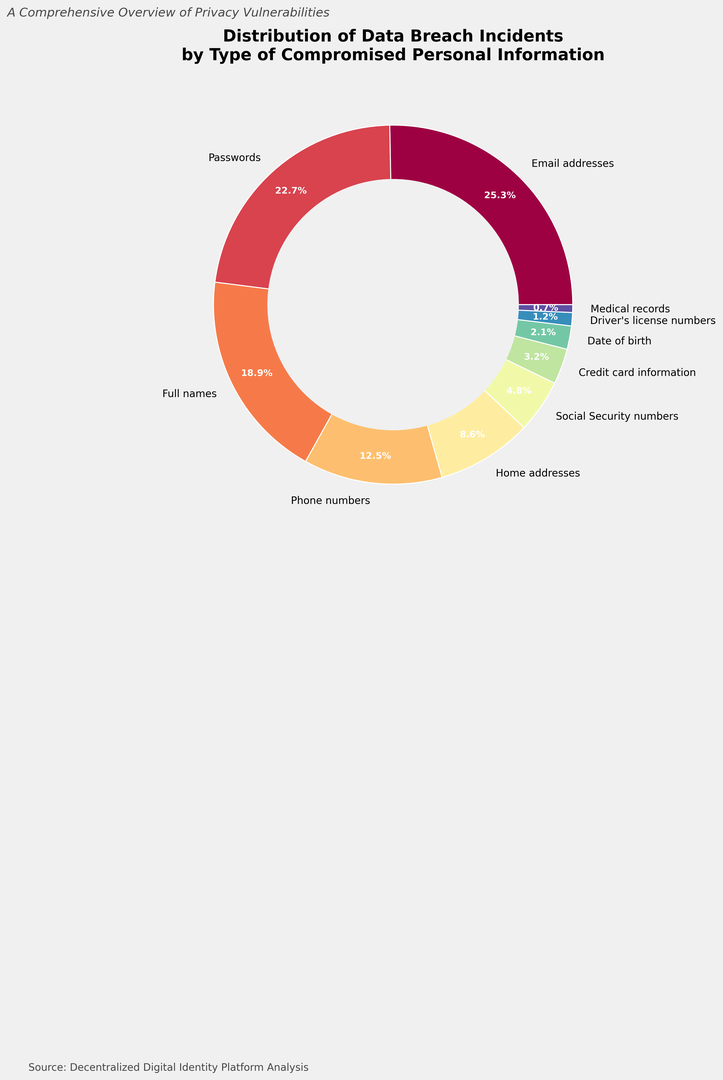Which type of compromised information is the most common? The figure shows that the percentage for email addresses is the largest slice of the donut chart.
Answer: Email addresses Which two types of compromised information are almost equally common? The percentages for email addresses and passwords are very close, with 25.3% and 22.7% respectively.
Answer: Email addresses and passwords What percentage of data breaches involve less common types of compromised information, like date of birth, driver's license numbers, and medical records combined? Adding up the percentages for date of birth (2.1%), driver's license numbers (1.2%), and medical records (0.7%) gives 2.1 + 1.2 + 0.7 = 4.0%.
Answer: 4.0% Which type of compromised information has the smallest percentage? The smallest slice on the chart represents medical records, which is 0.7%.
Answer: Medical records Is the percentage of breaches involving phone numbers greater than the percentage involving home addresses? The figure shows phone numbers at 12.5% and home addresses at 8.6%, so phone numbers have a greater percentage.
Answer: Yes What are the combined percentages of breaches involving both full names and phone numbers? Adding the percentages for full names (18.9%) and phone numbers (12.5%) gives 18.9 + 12.5 = 31.4%.
Answer: 31.4% How does the percentage of breaches involving passwords compare to that involving Social Security numbers? The percentage for passwords (22.7%) is much higher than that for Social Security numbers (4.8%).
Answer: Passwords Which type of compromised information accounts for less than 5% of breaches? The figure shows that Social Security numbers (4.8%), credit card information (3.2%), date of birth (2.1%), driver's license numbers (1.2%), and medical records (0.7%) all account for less than 5%.
Answer: Social Security numbers, credit card information, date of birth, driver's license numbers, and medical records What percentage of breaches involve full names or phone numbers? Adding the percentages for full names (18.9%) and phone numbers (12.5%) gives 18.9 + 12.5 = 31.4%.
Answer: 31.4% If you combine the percentages of breaches involving passwords and email addresses, what portion of all breaches do they represent? Adding the percentages for passwords (22.7%) and email addresses (25.3%) gives 22.7 + 25.3 = 48.0%.
Answer: 48.0% 